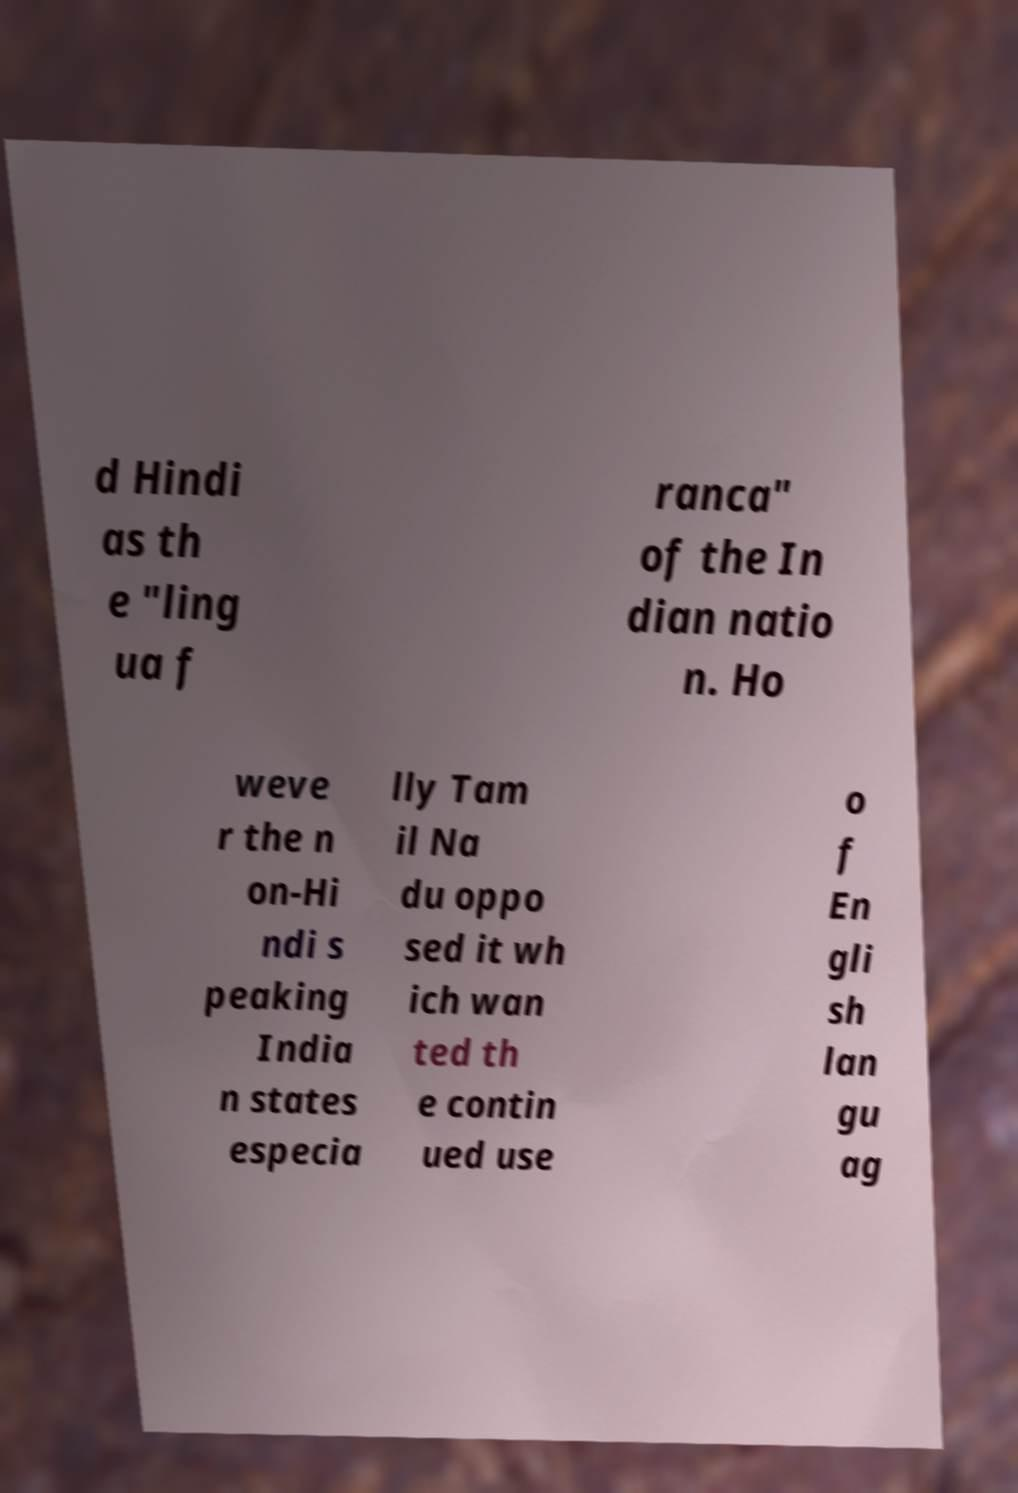Please read and relay the text visible in this image. What does it say? d Hindi as th e "ling ua f ranca" of the In dian natio n. Ho weve r the n on-Hi ndi s peaking India n states especia lly Tam il Na du oppo sed it wh ich wan ted th e contin ued use o f En gli sh lan gu ag 